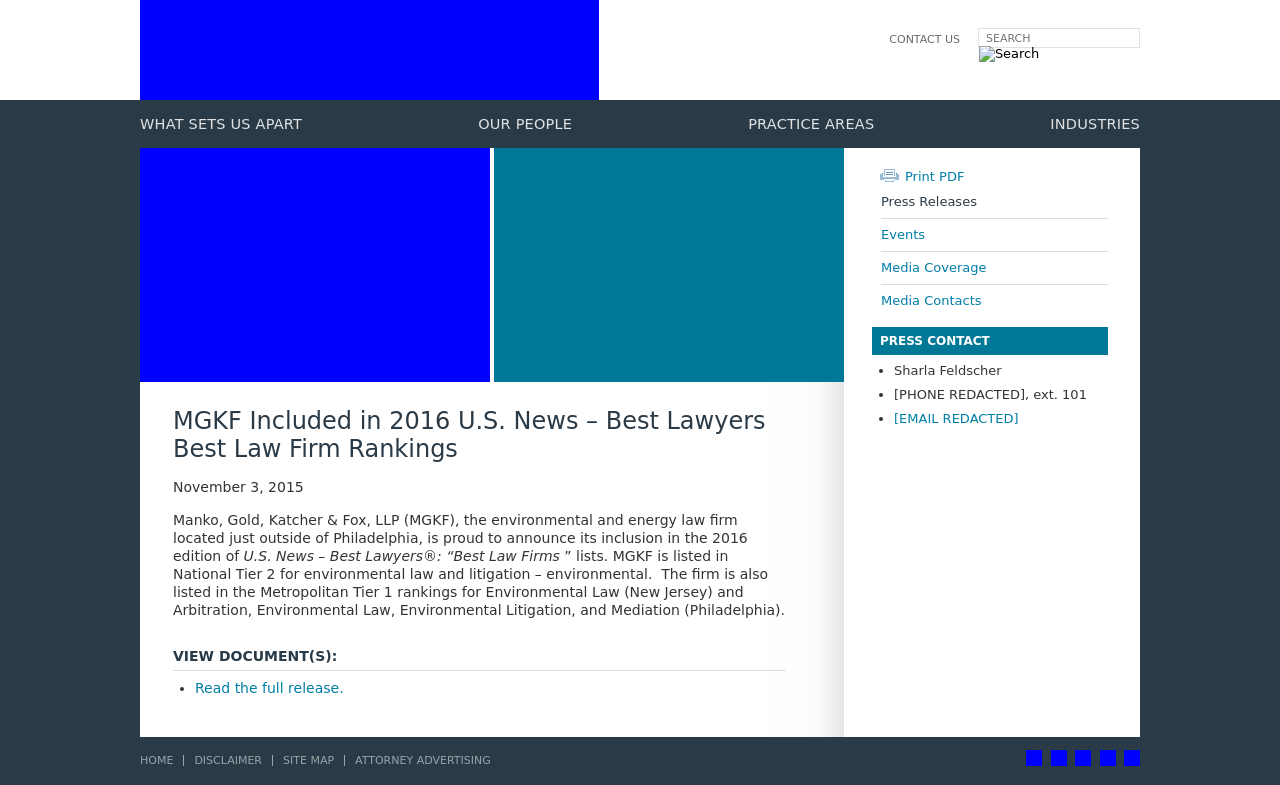What details can you provide about the firm's achievements as highlighted on this website? The website highlights the law firm's ranking in the 2016 edition of U.S. News – Best Lawyers 'Best Law Firms'. It specifically mentions that the firm is annually rated in National Tier 2 for Environmental Law and Litigation – Environmental. Additionally, it ranks in Metropolitan Tier 1 for several categories in different states, reflecting its strong regional presence and expertise in environmental law.  Can you tell me what the 'View Document(s): Read the full release' section is likely about? This section provides a link to a more detailed document or press release that further elaborates on the firm's rankings and achievements. It likely contains extensive details such as specific areas of practice in which the firm excels, historical context or quotes from partners, and possibly more about their methodology for securing high rankings in these respected lists. 